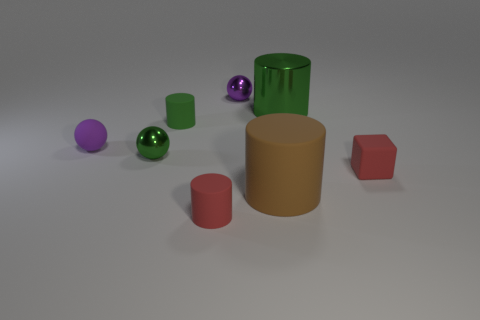How many green cylinders must be subtracted to get 1 green cylinders? 1 Add 2 tiny metallic balls. How many objects exist? 10 Subtract all green balls. How many balls are left? 2 Subtract 3 cylinders. How many cylinders are left? 1 Subtract all rubber objects. Subtract all tiny yellow rubber cubes. How many objects are left? 3 Add 3 small rubber spheres. How many small rubber spheres are left? 4 Add 7 green balls. How many green balls exist? 8 Subtract all green cylinders. How many cylinders are left? 2 Subtract 2 purple spheres. How many objects are left? 6 Subtract all balls. How many objects are left? 5 